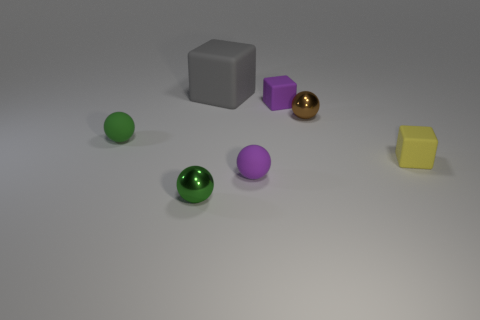Is there anything else that is the same size as the gray cube?
Your response must be concise. No. Do the purple sphere and the small brown thing have the same material?
Offer a terse response. No. What size is the yellow thing that is the same material as the large gray thing?
Provide a short and direct response. Small. There is a small object that is on the left side of the tiny green sphere that is on the right side of the small matte object that is left of the large object; what shape is it?
Keep it short and to the point. Sphere. There is a purple rubber thing that is the same shape as the brown metal object; what size is it?
Keep it short and to the point. Small. What size is the rubber thing that is left of the purple ball and on the right side of the small green metal thing?
Your answer should be compact. Large. What is the color of the large object?
Your answer should be compact. Gray. There is a gray thing that is to the left of the yellow rubber block; what size is it?
Your answer should be very brief. Large. How many small purple spheres are behind the small yellow block that is in front of the tiny shiny ball that is right of the large cube?
Offer a terse response. 0. There is a shiny thing that is in front of the tiny shiny object on the right side of the purple cube; what is its color?
Your answer should be very brief. Green. 